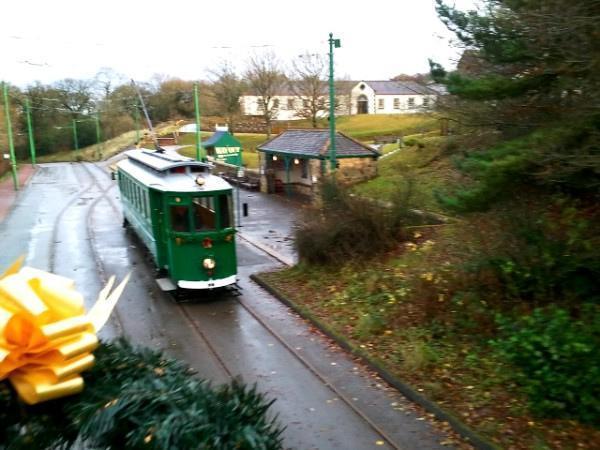What holiday is most likely next?
Pick the right solution, then justify: 'Answer: answer
Rationale: rationale.'
Options: Christmas, thanksgiving, halloween, easter. Answer: christmas.
Rationale: There is a holiday wreath in the picture, which tells you the holiday coming. 